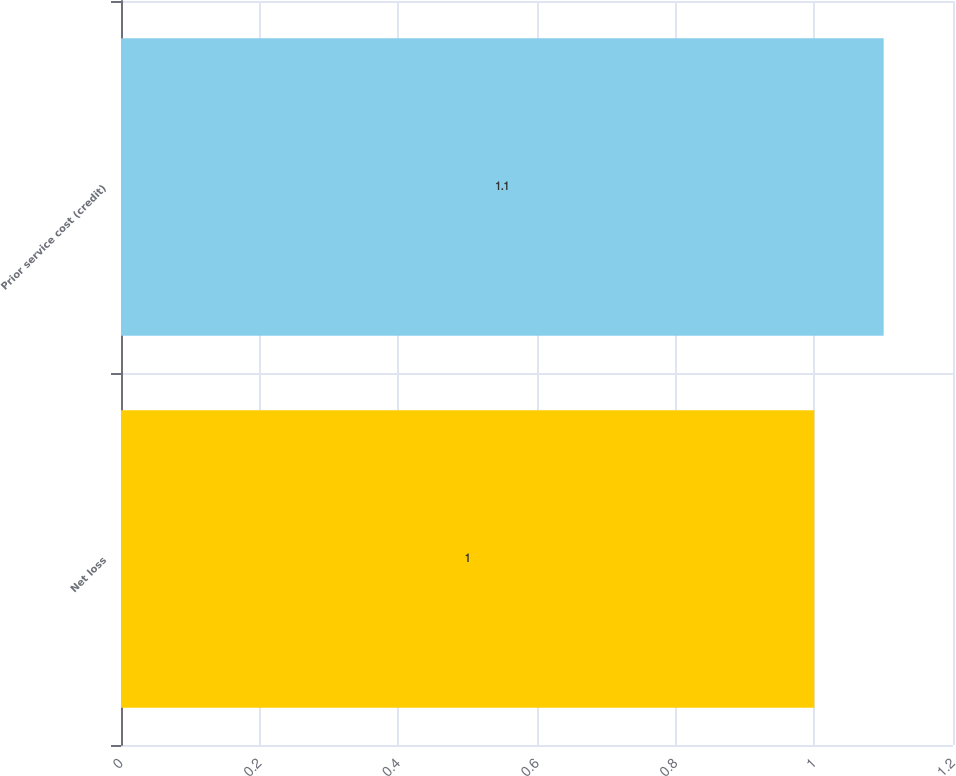Convert chart. <chart><loc_0><loc_0><loc_500><loc_500><bar_chart><fcel>Net loss<fcel>Prior service cost (credit)<nl><fcel>1<fcel>1.1<nl></chart> 